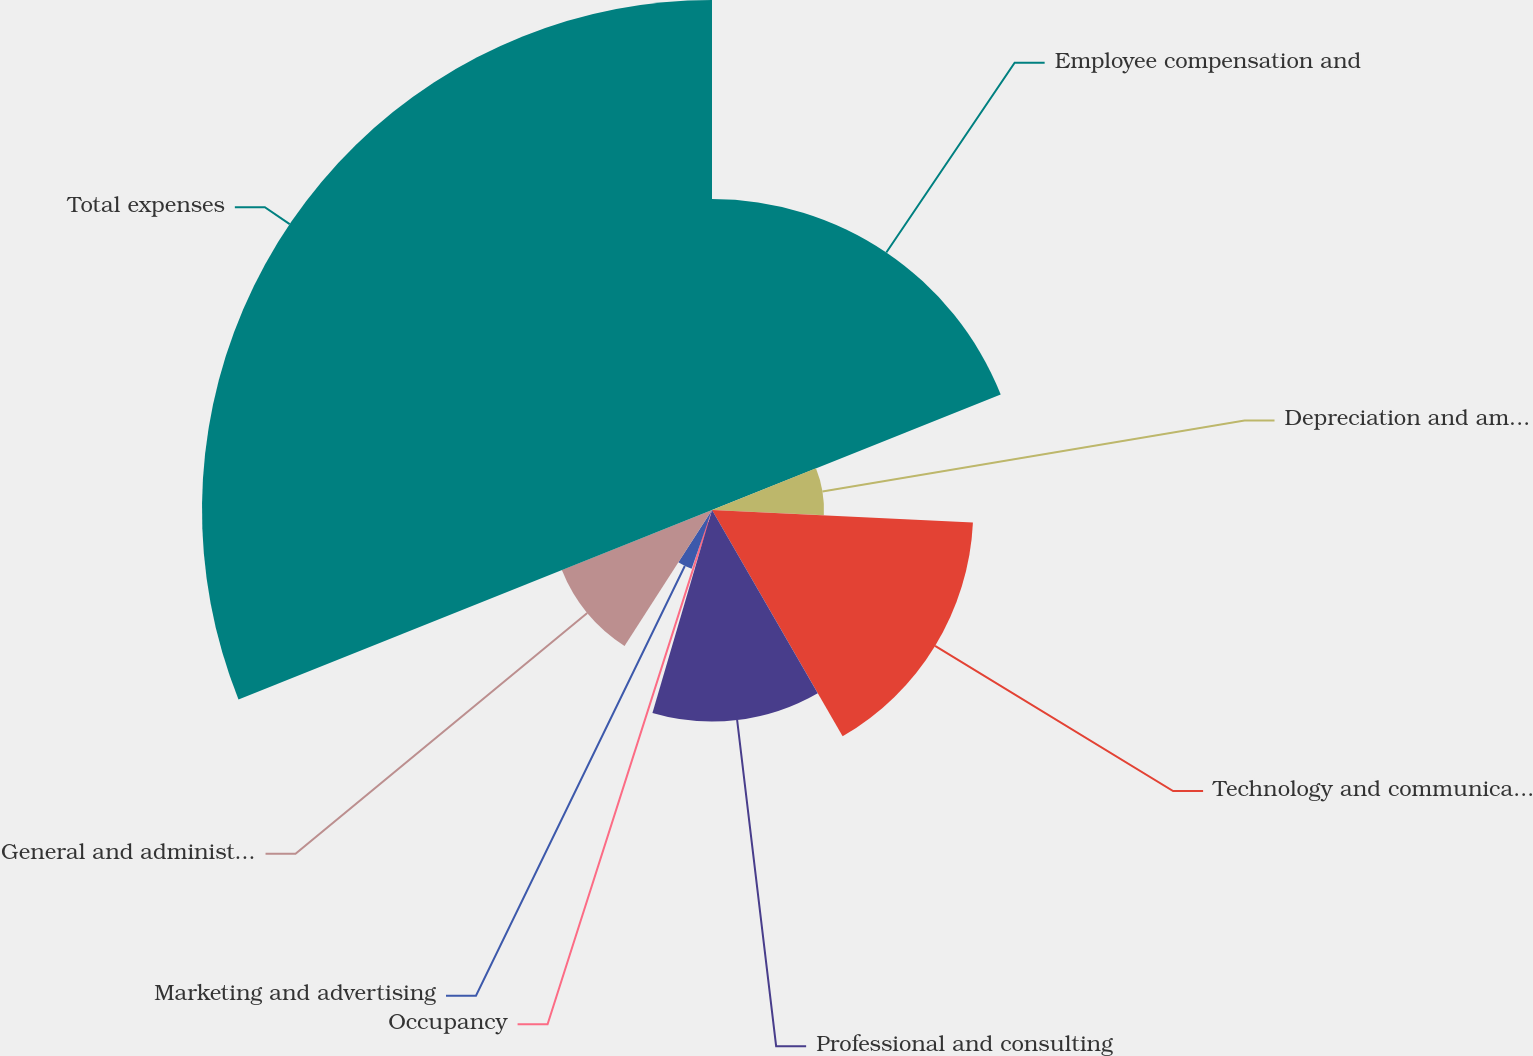Convert chart. <chart><loc_0><loc_0><loc_500><loc_500><pie_chart><fcel>Employee compensation and<fcel>Depreciation and amortization<fcel>Technology and communications<fcel>Professional and consulting<fcel>Occupancy<fcel>Marketing and advertising<fcel>General and administrative<fcel>Total expenses<nl><fcel>18.94%<fcel>6.82%<fcel>15.91%<fcel>12.88%<fcel>0.76%<fcel>3.79%<fcel>9.85%<fcel>31.06%<nl></chart> 